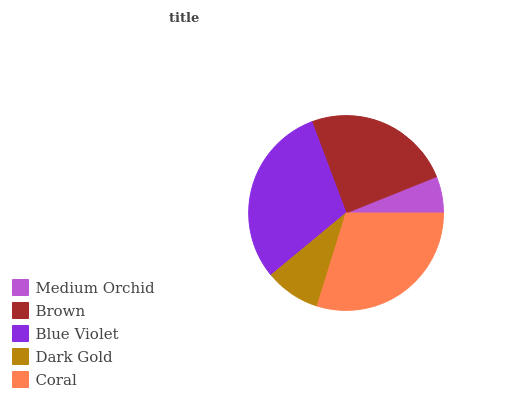Is Medium Orchid the minimum?
Answer yes or no. Yes. Is Blue Violet the maximum?
Answer yes or no. Yes. Is Brown the minimum?
Answer yes or no. No. Is Brown the maximum?
Answer yes or no. No. Is Brown greater than Medium Orchid?
Answer yes or no. Yes. Is Medium Orchid less than Brown?
Answer yes or no. Yes. Is Medium Orchid greater than Brown?
Answer yes or no. No. Is Brown less than Medium Orchid?
Answer yes or no. No. Is Brown the high median?
Answer yes or no. Yes. Is Brown the low median?
Answer yes or no. Yes. Is Blue Violet the high median?
Answer yes or no. No. Is Medium Orchid the low median?
Answer yes or no. No. 